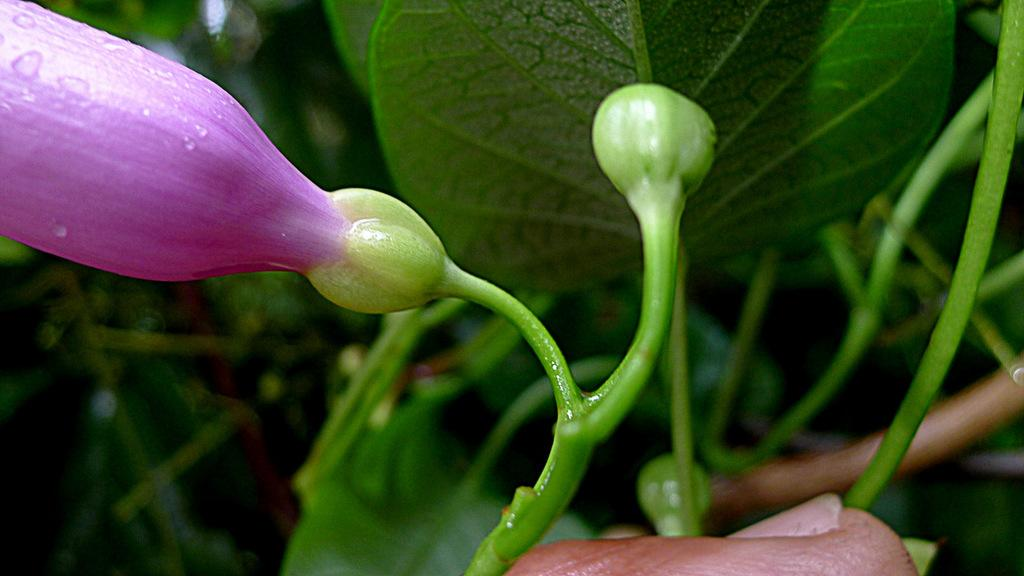What type of living organism can be seen in the image? There is a plant in the image. What part of the plant is particularly noticeable in the image? There is a flower associated with the plant in the image. What type of chicken is visible in the image? There is no chicken present in the image; it features a plant with a flower. 